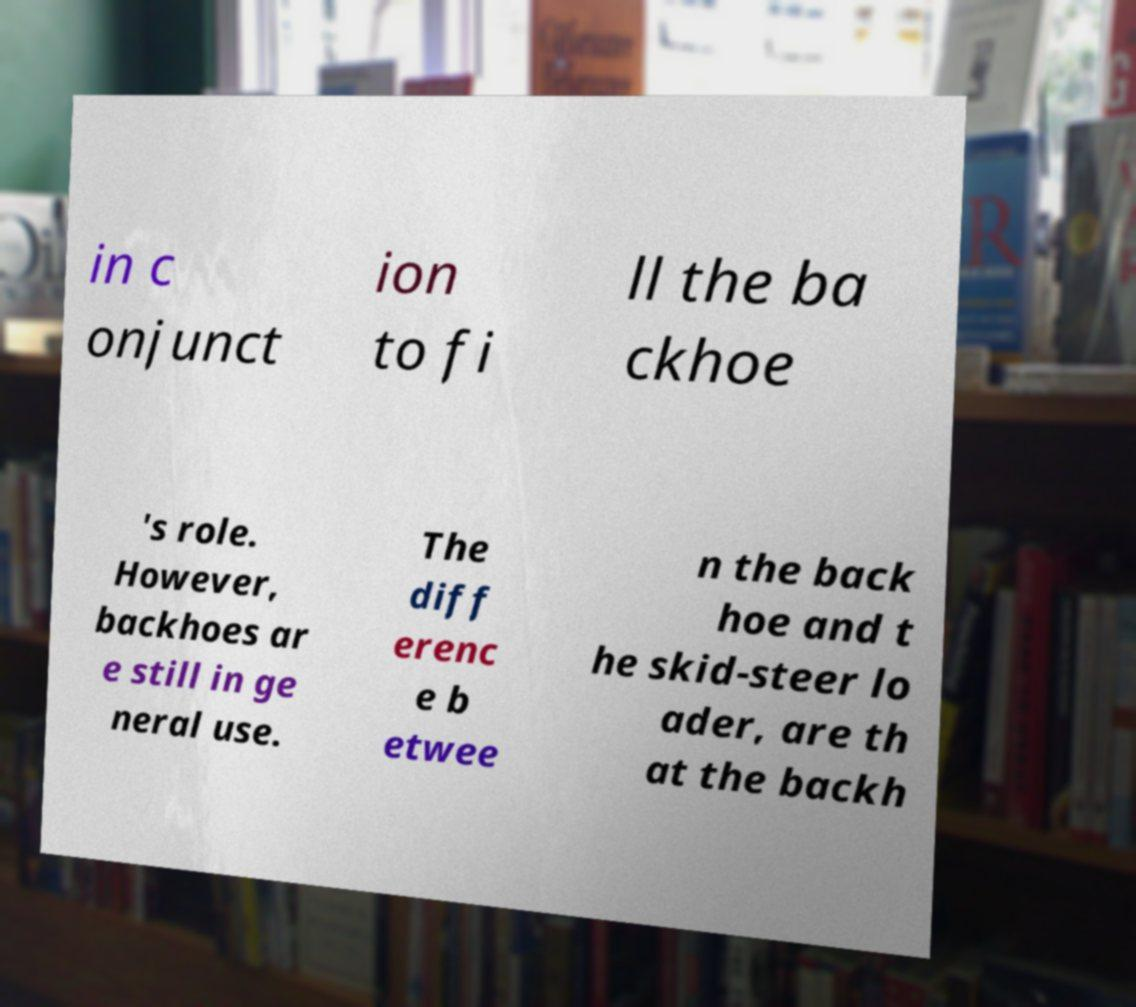For documentation purposes, I need the text within this image transcribed. Could you provide that? in c onjunct ion to fi ll the ba ckhoe 's role. However, backhoes ar e still in ge neral use. The diff erenc e b etwee n the back hoe and t he skid-steer lo ader, are th at the backh 